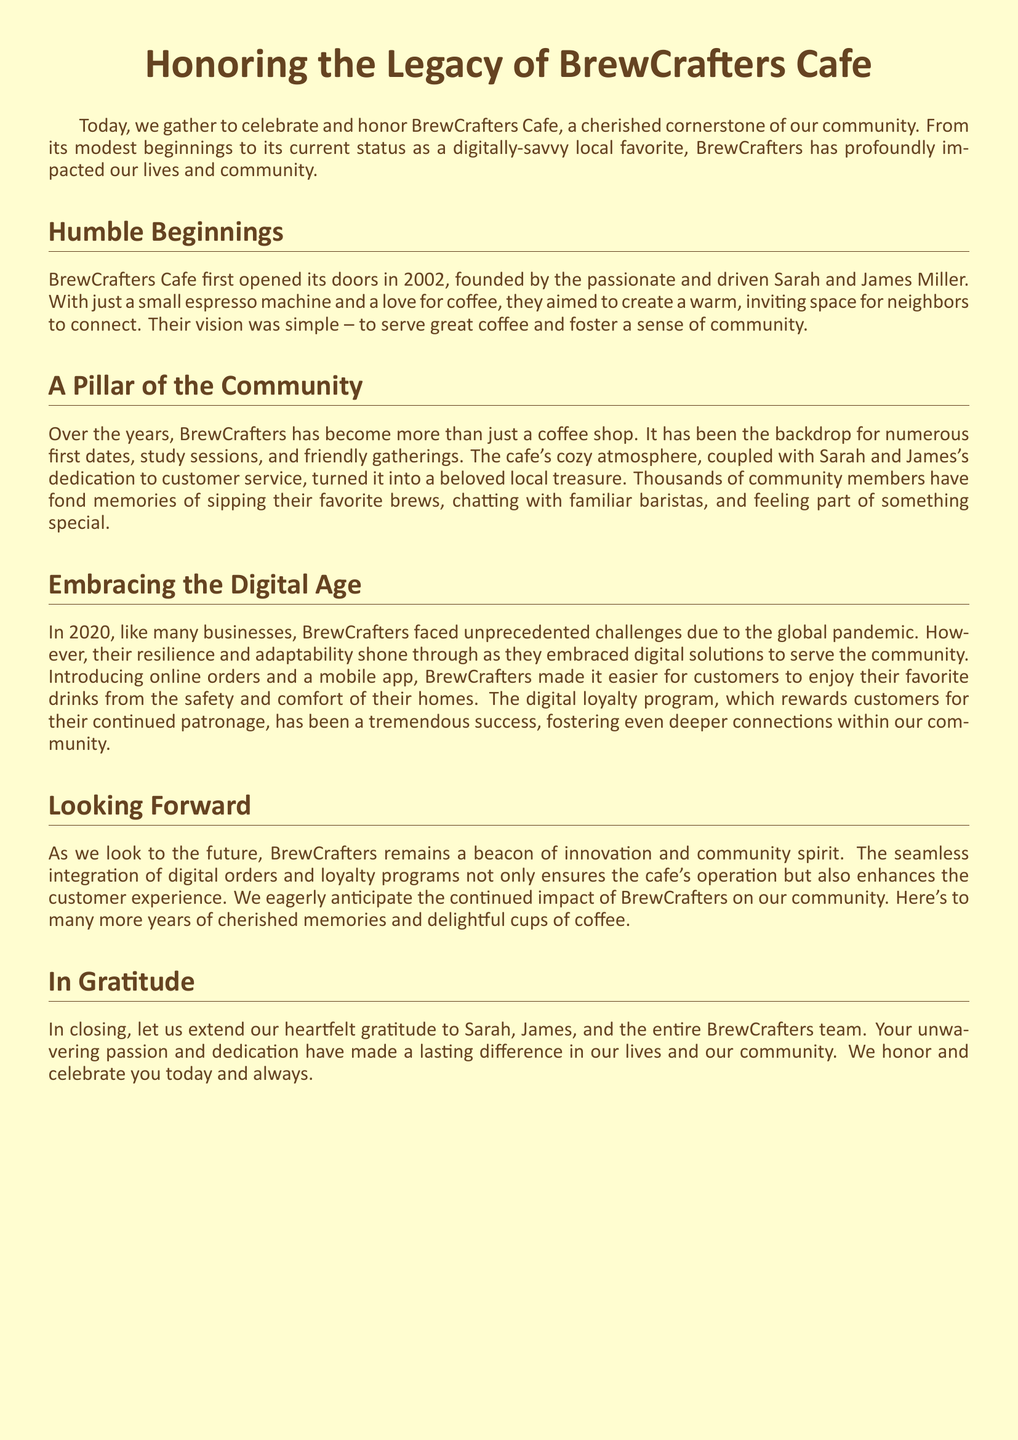What year did BrewCrafters Cafe open? The document states that BrewCrafters Cafe first opened its doors in 2002.
Answer: 2002 Who are the founders of BrewCrafters Cafe? The document mentions that Sarah and James Miller founded BrewCrafters Cafe.
Answer: Sarah and James Miller What were the original offerings of BrewCrafters? The document indicates that the cafe started with a small espresso machine and great coffee.
Answer: Small espresso machine and coffee What significant change did BrewCrafters make in 2020? The document describes how BrewCrafters embraced digital solutions, including online orders.
Answer: Embraced digital solutions What is the purpose of the digital loyalty program? The text states that the loyalty program rewards customers for their continued patronage.
Answer: Rewards continued patronage What role does BrewCrafters play in the community? The document refers to BrewCrafters as a cherished cornerstone of the community.
Answer: Cherished cornerstone How do the founders feel about their impact on the community? The document expresses heartfelt gratitude to the founders for their passion and dedication.
Answer: Heartfelt gratitude What kind of atmosphere does BrewCrafters provide? The cafe is described as cozy, turning it into a beloved local treasure.
Answer: Cozy atmosphere 